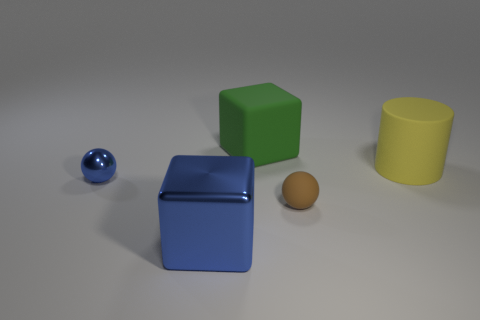Does the metal cube have the same color as the tiny shiny thing?
Your response must be concise. Yes. The thing that is on the right side of the big blue thing and in front of the matte cylinder has what shape?
Your answer should be compact. Sphere. How many other things are there of the same color as the tiny metal ball?
Ensure brevity in your answer.  1. The green thing is what shape?
Your answer should be compact. Cube. What color is the tiny object in front of the small object that is to the left of the large blue shiny object?
Give a very brief answer. Brown. Is the color of the metal cube the same as the cube behind the large yellow rubber cylinder?
Your answer should be compact. No. What is the thing that is to the left of the big green thing and on the right side of the blue ball made of?
Your answer should be very brief. Metal. Are there any rubber cylinders of the same size as the blue cube?
Keep it short and to the point. Yes. What material is the green object that is the same size as the yellow thing?
Your response must be concise. Rubber. There is a yellow cylinder; how many green matte objects are to the right of it?
Provide a succinct answer. 0. 